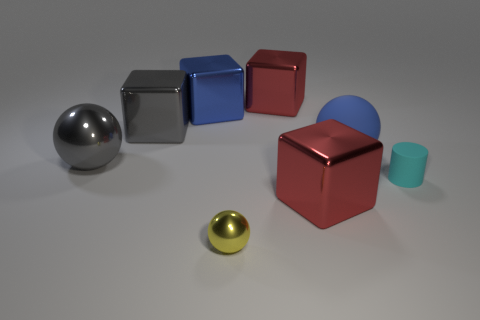Subtract all big blue matte balls. How many balls are left? 2 Add 1 blue matte things. How many objects exist? 9 Subtract all green balls. How many red cubes are left? 2 Subtract 1 cubes. How many cubes are left? 3 Subtract all balls. How many objects are left? 5 Subtract all blue blocks. How many blocks are left? 3 Add 2 tiny matte cylinders. How many tiny matte cylinders are left? 3 Add 3 large red metallic cubes. How many large red metallic cubes exist? 5 Subtract 0 red cylinders. How many objects are left? 8 Subtract all gray cubes. Subtract all gray spheres. How many cubes are left? 3 